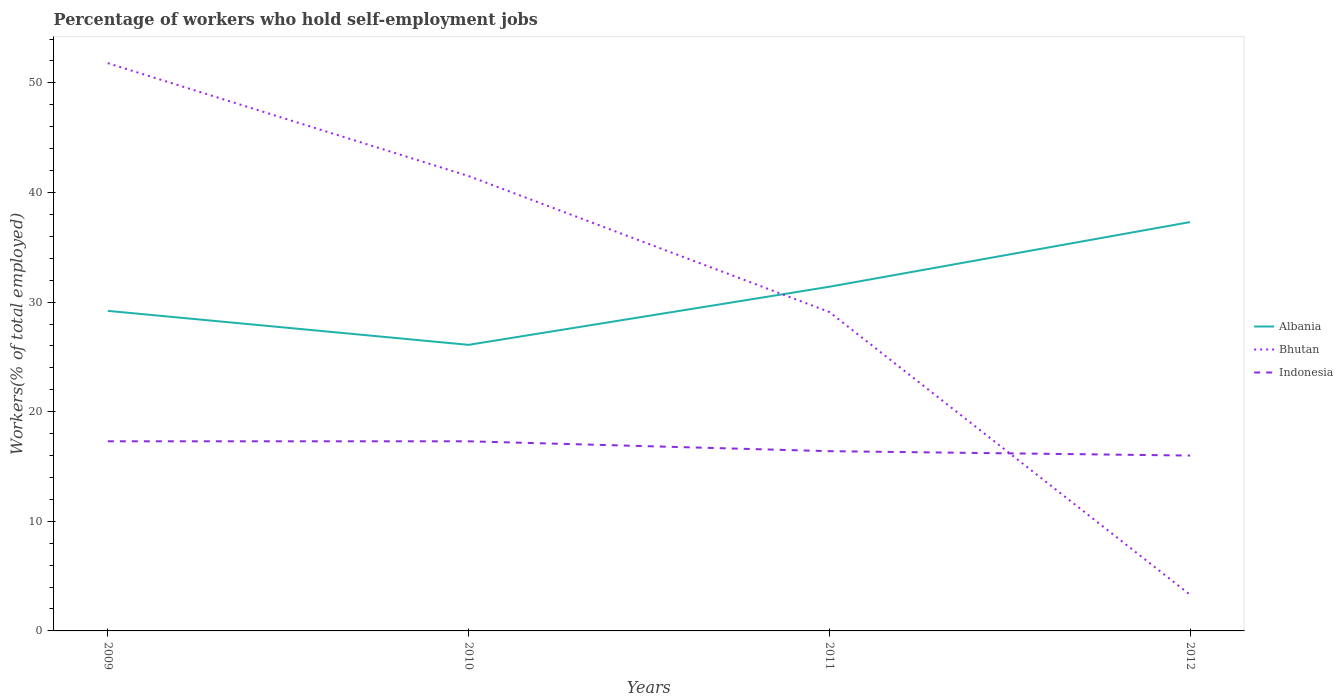Across all years, what is the maximum percentage of self-employed workers in Albania?
Give a very brief answer. 26.1. In which year was the percentage of self-employed workers in Indonesia maximum?
Provide a short and direct response. 2012. What is the total percentage of self-employed workers in Indonesia in the graph?
Provide a short and direct response. 0.4. What is the difference between the highest and the second highest percentage of self-employed workers in Albania?
Your response must be concise. 11.2. Is the percentage of self-employed workers in Albania strictly greater than the percentage of self-employed workers in Indonesia over the years?
Your answer should be compact. No. How many years are there in the graph?
Provide a succinct answer. 4. Does the graph contain grids?
Give a very brief answer. No. Where does the legend appear in the graph?
Keep it short and to the point. Center right. How many legend labels are there?
Offer a terse response. 3. What is the title of the graph?
Give a very brief answer. Percentage of workers who hold self-employment jobs. What is the label or title of the Y-axis?
Your answer should be very brief. Workers(% of total employed). What is the Workers(% of total employed) in Albania in 2009?
Ensure brevity in your answer.  29.2. What is the Workers(% of total employed) of Bhutan in 2009?
Provide a succinct answer. 51.8. What is the Workers(% of total employed) in Indonesia in 2009?
Your answer should be compact. 17.3. What is the Workers(% of total employed) in Albania in 2010?
Provide a short and direct response. 26.1. What is the Workers(% of total employed) of Bhutan in 2010?
Ensure brevity in your answer.  41.5. What is the Workers(% of total employed) in Indonesia in 2010?
Provide a succinct answer. 17.3. What is the Workers(% of total employed) in Albania in 2011?
Give a very brief answer. 31.4. What is the Workers(% of total employed) of Bhutan in 2011?
Make the answer very short. 29.1. What is the Workers(% of total employed) in Indonesia in 2011?
Your answer should be very brief. 16.4. What is the Workers(% of total employed) of Albania in 2012?
Your answer should be very brief. 37.3. What is the Workers(% of total employed) of Bhutan in 2012?
Keep it short and to the point. 3.3. Across all years, what is the maximum Workers(% of total employed) of Albania?
Provide a short and direct response. 37.3. Across all years, what is the maximum Workers(% of total employed) of Bhutan?
Your response must be concise. 51.8. Across all years, what is the maximum Workers(% of total employed) in Indonesia?
Your answer should be very brief. 17.3. Across all years, what is the minimum Workers(% of total employed) of Albania?
Your answer should be very brief. 26.1. Across all years, what is the minimum Workers(% of total employed) in Bhutan?
Your answer should be compact. 3.3. What is the total Workers(% of total employed) in Albania in the graph?
Make the answer very short. 124. What is the total Workers(% of total employed) in Bhutan in the graph?
Offer a terse response. 125.7. What is the total Workers(% of total employed) of Indonesia in the graph?
Provide a succinct answer. 67. What is the difference between the Workers(% of total employed) of Bhutan in 2009 and that in 2010?
Give a very brief answer. 10.3. What is the difference between the Workers(% of total employed) in Bhutan in 2009 and that in 2011?
Your response must be concise. 22.7. What is the difference between the Workers(% of total employed) of Albania in 2009 and that in 2012?
Your answer should be compact. -8.1. What is the difference between the Workers(% of total employed) of Bhutan in 2009 and that in 2012?
Give a very brief answer. 48.5. What is the difference between the Workers(% of total employed) in Bhutan in 2010 and that in 2012?
Your answer should be compact. 38.2. What is the difference between the Workers(% of total employed) of Albania in 2011 and that in 2012?
Provide a short and direct response. -5.9. What is the difference between the Workers(% of total employed) in Bhutan in 2011 and that in 2012?
Keep it short and to the point. 25.8. What is the difference between the Workers(% of total employed) in Indonesia in 2011 and that in 2012?
Ensure brevity in your answer.  0.4. What is the difference between the Workers(% of total employed) in Albania in 2009 and the Workers(% of total employed) in Bhutan in 2010?
Your response must be concise. -12.3. What is the difference between the Workers(% of total employed) of Albania in 2009 and the Workers(% of total employed) of Indonesia in 2010?
Give a very brief answer. 11.9. What is the difference between the Workers(% of total employed) in Bhutan in 2009 and the Workers(% of total employed) in Indonesia in 2010?
Keep it short and to the point. 34.5. What is the difference between the Workers(% of total employed) of Albania in 2009 and the Workers(% of total employed) of Bhutan in 2011?
Ensure brevity in your answer.  0.1. What is the difference between the Workers(% of total employed) in Albania in 2009 and the Workers(% of total employed) in Indonesia in 2011?
Make the answer very short. 12.8. What is the difference between the Workers(% of total employed) of Bhutan in 2009 and the Workers(% of total employed) of Indonesia in 2011?
Provide a short and direct response. 35.4. What is the difference between the Workers(% of total employed) of Albania in 2009 and the Workers(% of total employed) of Bhutan in 2012?
Provide a short and direct response. 25.9. What is the difference between the Workers(% of total employed) in Albania in 2009 and the Workers(% of total employed) in Indonesia in 2012?
Provide a short and direct response. 13.2. What is the difference between the Workers(% of total employed) of Bhutan in 2009 and the Workers(% of total employed) of Indonesia in 2012?
Give a very brief answer. 35.8. What is the difference between the Workers(% of total employed) of Bhutan in 2010 and the Workers(% of total employed) of Indonesia in 2011?
Your answer should be very brief. 25.1. What is the difference between the Workers(% of total employed) of Albania in 2010 and the Workers(% of total employed) of Bhutan in 2012?
Offer a very short reply. 22.8. What is the difference between the Workers(% of total employed) in Bhutan in 2010 and the Workers(% of total employed) in Indonesia in 2012?
Your answer should be compact. 25.5. What is the difference between the Workers(% of total employed) in Albania in 2011 and the Workers(% of total employed) in Bhutan in 2012?
Offer a terse response. 28.1. What is the difference between the Workers(% of total employed) of Albania in 2011 and the Workers(% of total employed) of Indonesia in 2012?
Give a very brief answer. 15.4. What is the average Workers(% of total employed) of Bhutan per year?
Offer a very short reply. 31.43. What is the average Workers(% of total employed) in Indonesia per year?
Keep it short and to the point. 16.75. In the year 2009, what is the difference between the Workers(% of total employed) in Albania and Workers(% of total employed) in Bhutan?
Provide a short and direct response. -22.6. In the year 2009, what is the difference between the Workers(% of total employed) in Albania and Workers(% of total employed) in Indonesia?
Your response must be concise. 11.9. In the year 2009, what is the difference between the Workers(% of total employed) in Bhutan and Workers(% of total employed) in Indonesia?
Your response must be concise. 34.5. In the year 2010, what is the difference between the Workers(% of total employed) in Albania and Workers(% of total employed) in Bhutan?
Provide a short and direct response. -15.4. In the year 2010, what is the difference between the Workers(% of total employed) of Albania and Workers(% of total employed) of Indonesia?
Ensure brevity in your answer.  8.8. In the year 2010, what is the difference between the Workers(% of total employed) of Bhutan and Workers(% of total employed) of Indonesia?
Give a very brief answer. 24.2. In the year 2011, what is the difference between the Workers(% of total employed) of Albania and Workers(% of total employed) of Indonesia?
Your response must be concise. 15. In the year 2011, what is the difference between the Workers(% of total employed) of Bhutan and Workers(% of total employed) of Indonesia?
Ensure brevity in your answer.  12.7. In the year 2012, what is the difference between the Workers(% of total employed) in Albania and Workers(% of total employed) in Bhutan?
Offer a terse response. 34. In the year 2012, what is the difference between the Workers(% of total employed) of Albania and Workers(% of total employed) of Indonesia?
Provide a succinct answer. 21.3. In the year 2012, what is the difference between the Workers(% of total employed) of Bhutan and Workers(% of total employed) of Indonesia?
Make the answer very short. -12.7. What is the ratio of the Workers(% of total employed) in Albania in 2009 to that in 2010?
Offer a terse response. 1.12. What is the ratio of the Workers(% of total employed) of Bhutan in 2009 to that in 2010?
Give a very brief answer. 1.25. What is the ratio of the Workers(% of total employed) of Indonesia in 2009 to that in 2010?
Provide a succinct answer. 1. What is the ratio of the Workers(% of total employed) in Albania in 2009 to that in 2011?
Make the answer very short. 0.93. What is the ratio of the Workers(% of total employed) of Bhutan in 2009 to that in 2011?
Your answer should be compact. 1.78. What is the ratio of the Workers(% of total employed) of Indonesia in 2009 to that in 2011?
Provide a short and direct response. 1.05. What is the ratio of the Workers(% of total employed) in Albania in 2009 to that in 2012?
Offer a very short reply. 0.78. What is the ratio of the Workers(% of total employed) in Bhutan in 2009 to that in 2012?
Keep it short and to the point. 15.7. What is the ratio of the Workers(% of total employed) of Indonesia in 2009 to that in 2012?
Provide a succinct answer. 1.08. What is the ratio of the Workers(% of total employed) of Albania in 2010 to that in 2011?
Offer a very short reply. 0.83. What is the ratio of the Workers(% of total employed) in Bhutan in 2010 to that in 2011?
Give a very brief answer. 1.43. What is the ratio of the Workers(% of total employed) in Indonesia in 2010 to that in 2011?
Provide a succinct answer. 1.05. What is the ratio of the Workers(% of total employed) in Albania in 2010 to that in 2012?
Your answer should be very brief. 0.7. What is the ratio of the Workers(% of total employed) in Bhutan in 2010 to that in 2012?
Your response must be concise. 12.58. What is the ratio of the Workers(% of total employed) in Indonesia in 2010 to that in 2012?
Offer a very short reply. 1.08. What is the ratio of the Workers(% of total employed) in Albania in 2011 to that in 2012?
Make the answer very short. 0.84. What is the ratio of the Workers(% of total employed) in Bhutan in 2011 to that in 2012?
Make the answer very short. 8.82. What is the difference between the highest and the second highest Workers(% of total employed) of Albania?
Your answer should be very brief. 5.9. What is the difference between the highest and the second highest Workers(% of total employed) in Bhutan?
Your answer should be very brief. 10.3. What is the difference between the highest and the lowest Workers(% of total employed) in Albania?
Your answer should be compact. 11.2. What is the difference between the highest and the lowest Workers(% of total employed) in Bhutan?
Ensure brevity in your answer.  48.5. What is the difference between the highest and the lowest Workers(% of total employed) of Indonesia?
Give a very brief answer. 1.3. 